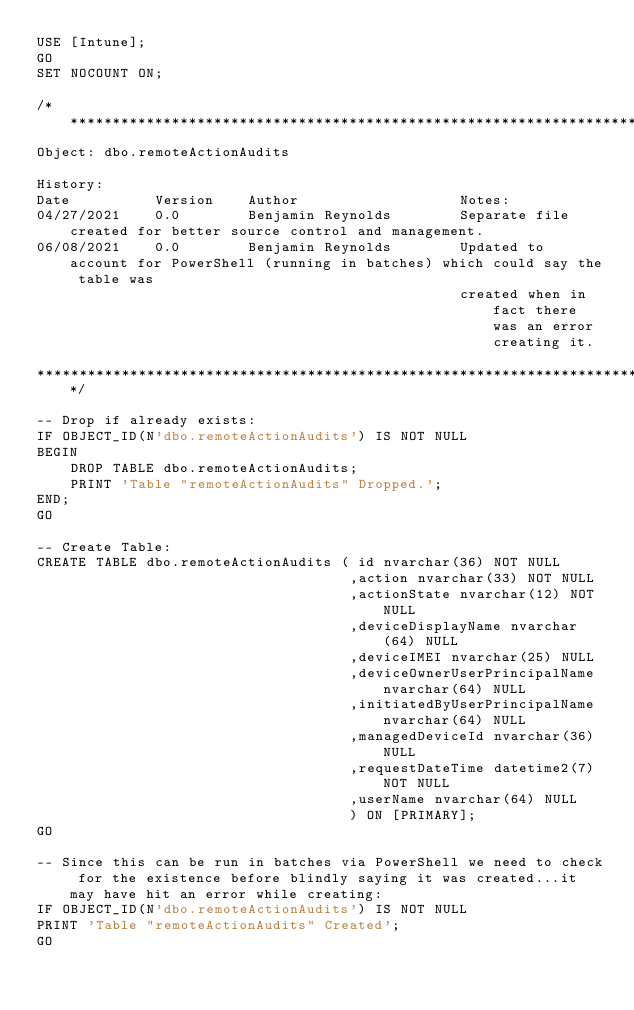Convert code to text. <code><loc_0><loc_0><loc_500><loc_500><_SQL_>USE [Intune];
GO
SET NOCOUNT ON;

/***************************************************************************************************************************
Object: dbo.remoteActionAudits

History:
Date          Version    Author                   Notes:
04/27/2021    0.0        Benjamin Reynolds        Separate file created for better source control and management.
06/08/2021    0.0        Benjamin Reynolds        Updated to account for PowerShell (running in batches) which could say the table was
                                                  created when in fact there was an error creating it.

***************************************************************************************************************************/

-- Drop if already exists:
IF OBJECT_ID(N'dbo.remoteActionAudits') IS NOT NULL
BEGIN
    DROP TABLE dbo.remoteActionAudits;
    PRINT 'Table "remoteActionAudits" Dropped.';
END;
GO

-- Create Table:
CREATE TABLE dbo.remoteActionAudits ( id nvarchar(36) NOT NULL
                                     ,action nvarchar(33) NOT NULL
                                     ,actionState nvarchar(12) NOT NULL
                                     ,deviceDisplayName nvarchar(64) NULL
                                     ,deviceIMEI nvarchar(25) NULL
                                     ,deviceOwnerUserPrincipalName nvarchar(64) NULL
                                     ,initiatedByUserPrincipalName nvarchar(64) NULL
                                     ,managedDeviceId nvarchar(36) NULL
                                     ,requestDateTime datetime2(7) NOT NULL
                                     ,userName nvarchar(64) NULL
                                     ) ON [PRIMARY];
GO

-- Since this can be run in batches via PowerShell we need to check for the existence before blindly saying it was created...it may have hit an error while creating:
IF OBJECT_ID(N'dbo.remoteActionAudits') IS NOT NULL
PRINT 'Table "remoteActionAudits" Created';
GO</code> 